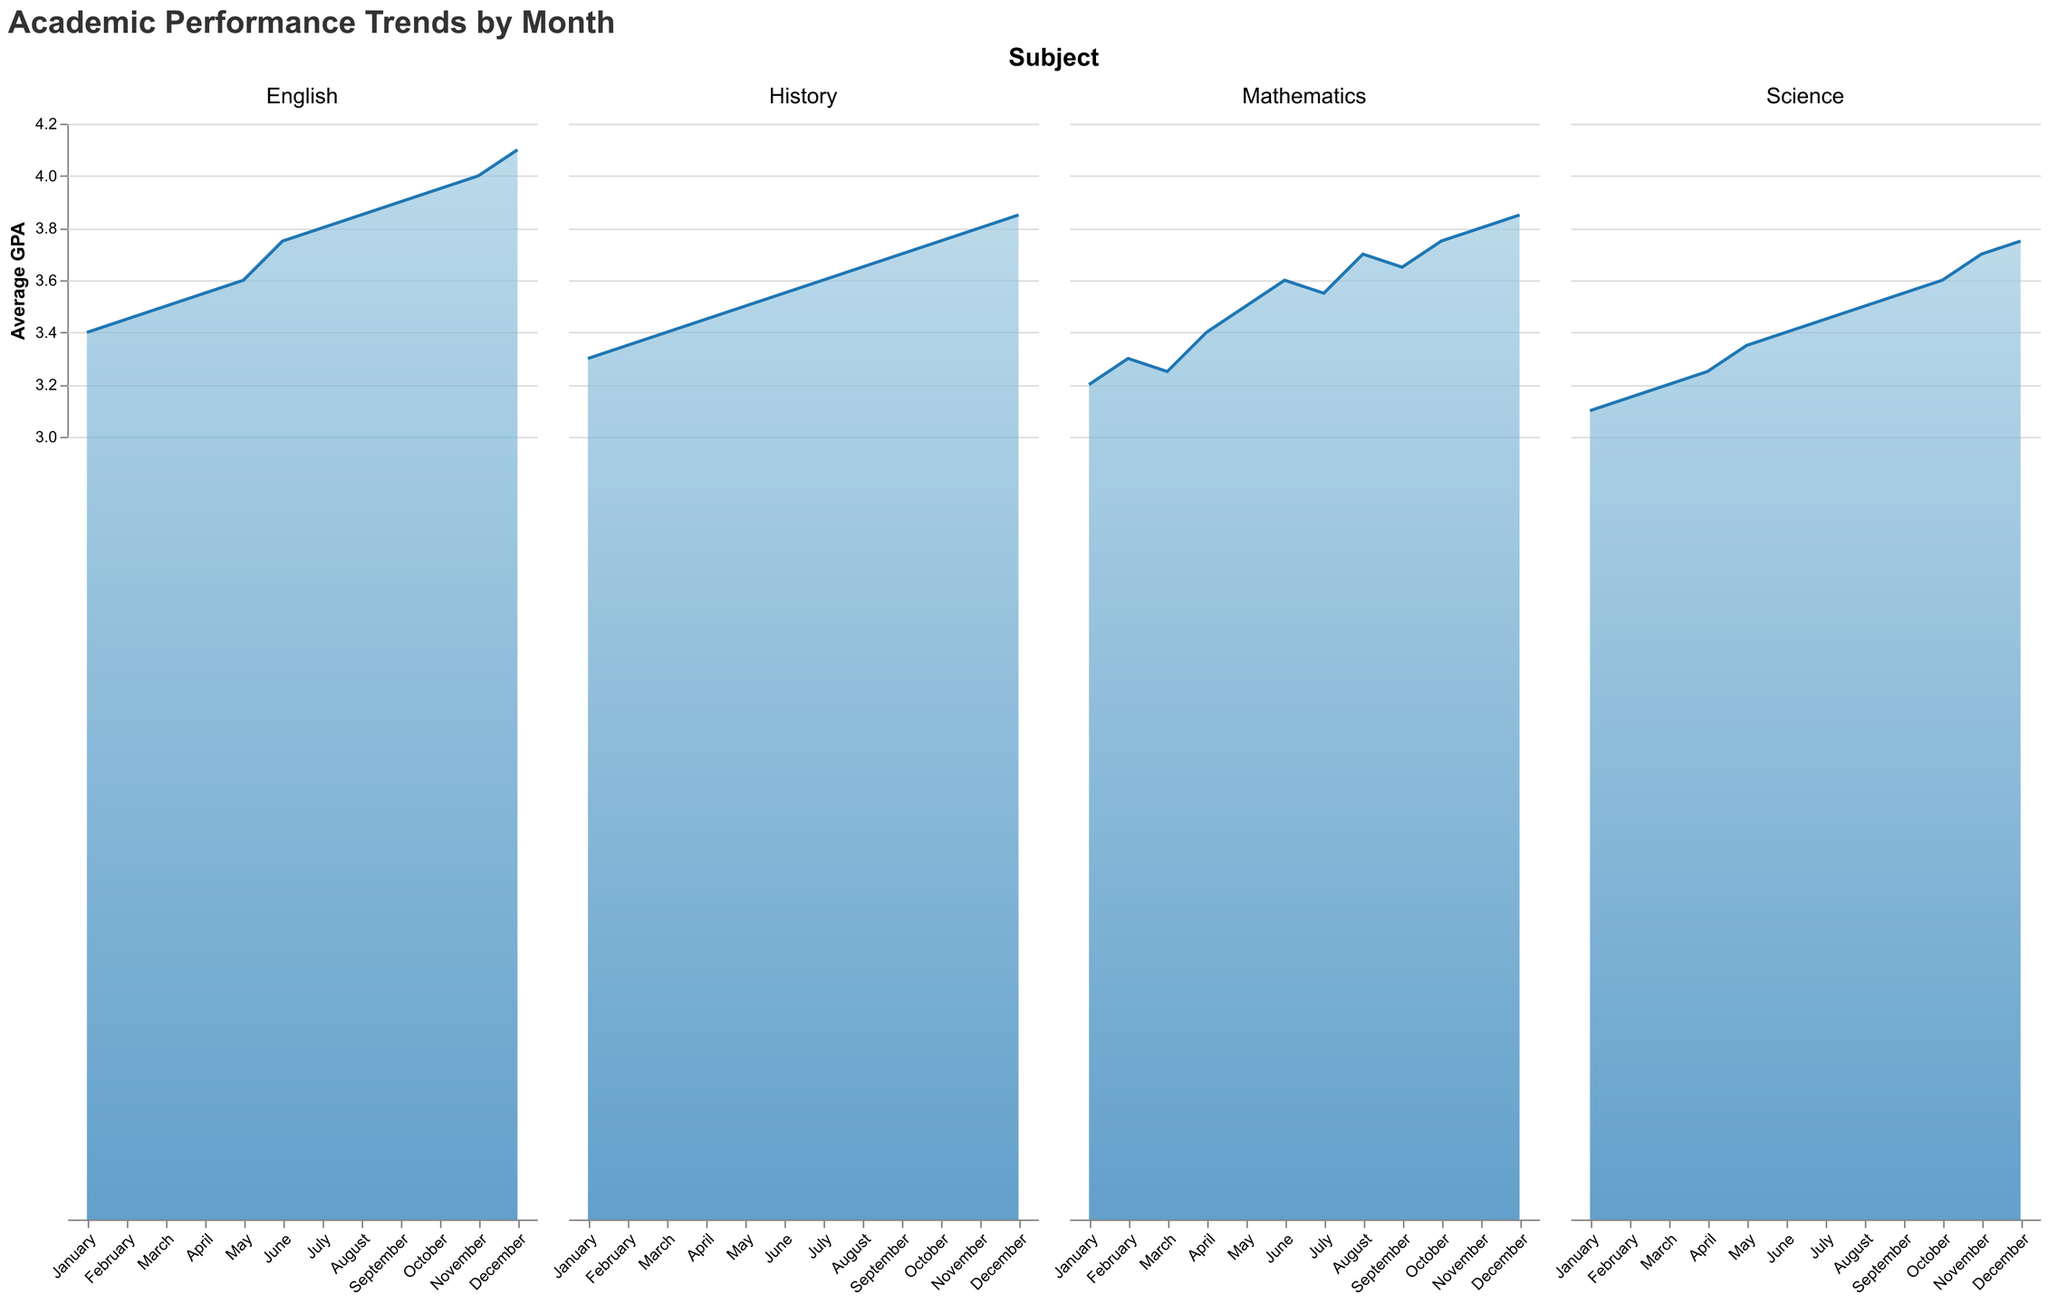What is the title of the figure? The title is displayed at the top of the figure and reads "Academic Performance Trends by Month".
Answer: Academic Performance Trends by Month How many subjects are compared in the figure? The figure has subplots for each subject, and there are four subplots labeled "Mathematics", "English", "Science", and "History".
Answer: 4 In which month does English have the highest average GPA? By looking at the area chart for English, the highest point on the y-axis is in December, corresponding to an average GPA of 4.1.
Answer: December Compare the average GPA of Mathematics in January and December. How much does it increase? Mathematics has an average GPA of 3.2 in January and 3.85 in December. The increase is 3.85 - 3.2.
Answer: 0.65 Which subject shows the most improved GPA from January to December? Analysis of increases for each subject: 
- Mathematics: 3.85 - 3.2 = 0.65
- English: 4.1 - 3.4 = 0.7
- Science: 3.75 - 3.1 = 0.65
- History: 3.85 - 3.3 = 0.55
The greatest improvement is in English.
Answer: English What is the average GPA for Science in the first quarter of the year (January to March)? The average GPA for Science in January, February, and March is (3.1 + 3.15 + 3.2)/3.
Answer: 3.15 Which month shows the highest overall GPA across all subjects? Summarize the GPA for each subject per month and determine the highest single value: 
- English: December (4.1)
- Mathematics: December (3.85)
- Science: December (3.75)
- History: December (3.85)
The highest GPA is for English in December.
Answer: December What is the rate of increase in GPA for History between January and June? GPA increase from January (3.3) to June (3.55). Calculate the rate: (3.55 - 3.3) / 6 months.
Answer: 0.0417 per month Which subject had the lowest average GPA in February? By comparing values in February's subplots:
- Mathematics: 3.3
- English: 3.45
- Science: 3.15
- History: 3.35
Science has the lowest average GPA in February.
Answer: Science Identify the month with the largest single month GPA increase in Mathematics. Observe month-to-month changes and identify the maximum increase:
- January to February: 0.1
- February to March: -0.05
- March to April: 0.15
- April to May: 0.1
- May to June: 0.1
- June to July: -0.05
- July to August: 0.15
- August to September: -0.05
- September to October: 0.1
- October to November: 0.05
- November to December: 0.05
Largest increase is March to April (0.15).
Answer: April 